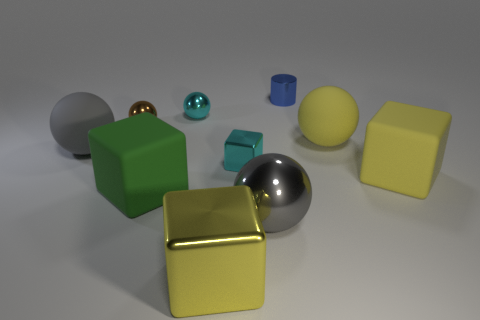Subtract 1 cubes. How many cubes are left? 3 Subtract all brown spheres. How many spheres are left? 4 Subtract all big yellow spheres. How many spheres are left? 4 Subtract all red spheres. Subtract all blue cylinders. How many spheres are left? 5 Subtract all cubes. How many objects are left? 6 Add 1 big gray objects. How many big gray objects are left? 3 Add 1 tiny cyan things. How many tiny cyan things exist? 3 Subtract 1 cyan balls. How many objects are left? 9 Subtract all cyan spheres. Subtract all big yellow spheres. How many objects are left? 8 